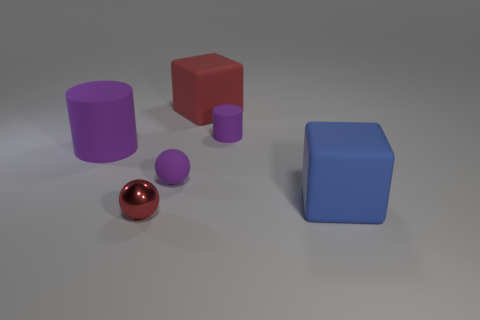Add 1 small metallic balls. How many objects exist? 7 Subtract all purple spheres. How many spheres are left? 1 Subtract all green balls. Subtract all brown cylinders. How many balls are left? 2 Subtract 0 yellow cylinders. How many objects are left? 6 Subtract all spheres. How many objects are left? 4 Subtract 1 balls. How many balls are left? 1 Subtract all blue spheres. How many brown cylinders are left? 0 Subtract all small purple cylinders. Subtract all matte balls. How many objects are left? 4 Add 3 big blue rubber blocks. How many big blue rubber blocks are left? 4 Add 1 big blue matte things. How many big blue matte things exist? 2 